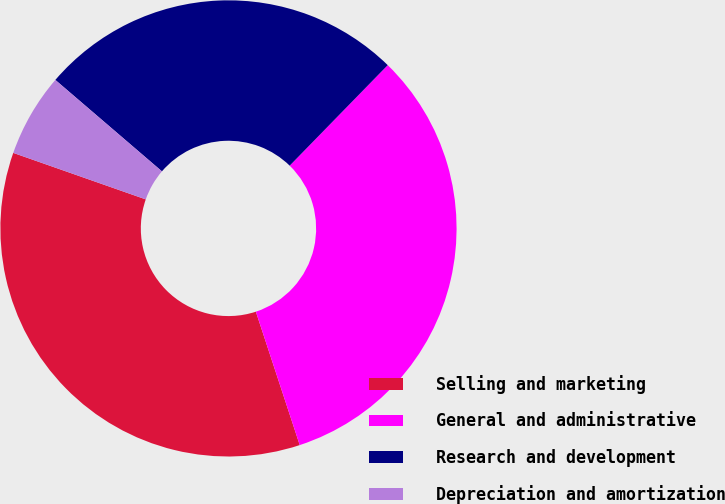Convert chart to OTSL. <chart><loc_0><loc_0><loc_500><loc_500><pie_chart><fcel>Selling and marketing<fcel>General and administrative<fcel>Research and development<fcel>Depreciation and amortization<nl><fcel>35.43%<fcel>32.64%<fcel>26.02%<fcel>5.91%<nl></chart> 